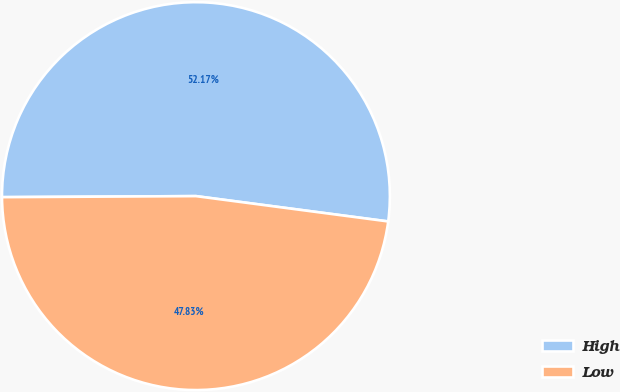Convert chart. <chart><loc_0><loc_0><loc_500><loc_500><pie_chart><fcel>High<fcel>Low<nl><fcel>52.17%<fcel>47.83%<nl></chart> 